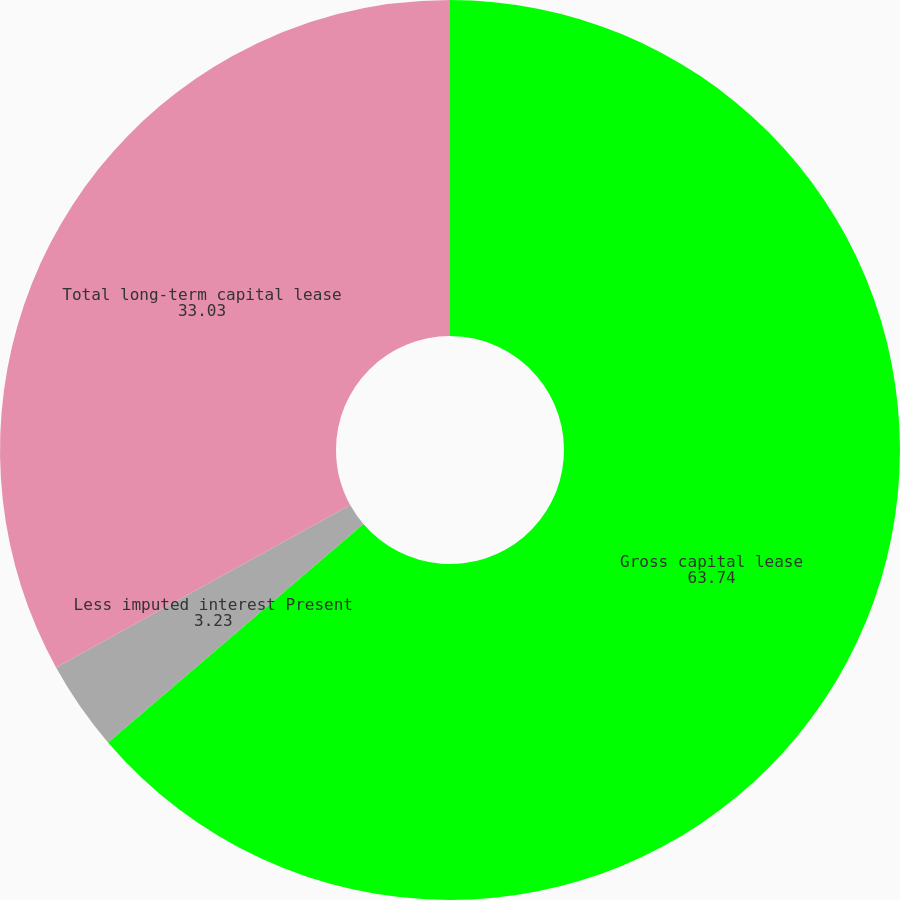Convert chart to OTSL. <chart><loc_0><loc_0><loc_500><loc_500><pie_chart><fcel>Gross capital lease<fcel>Less imputed interest Present<fcel>Total long-term capital lease<nl><fcel>63.74%<fcel>3.23%<fcel>33.03%<nl></chart> 